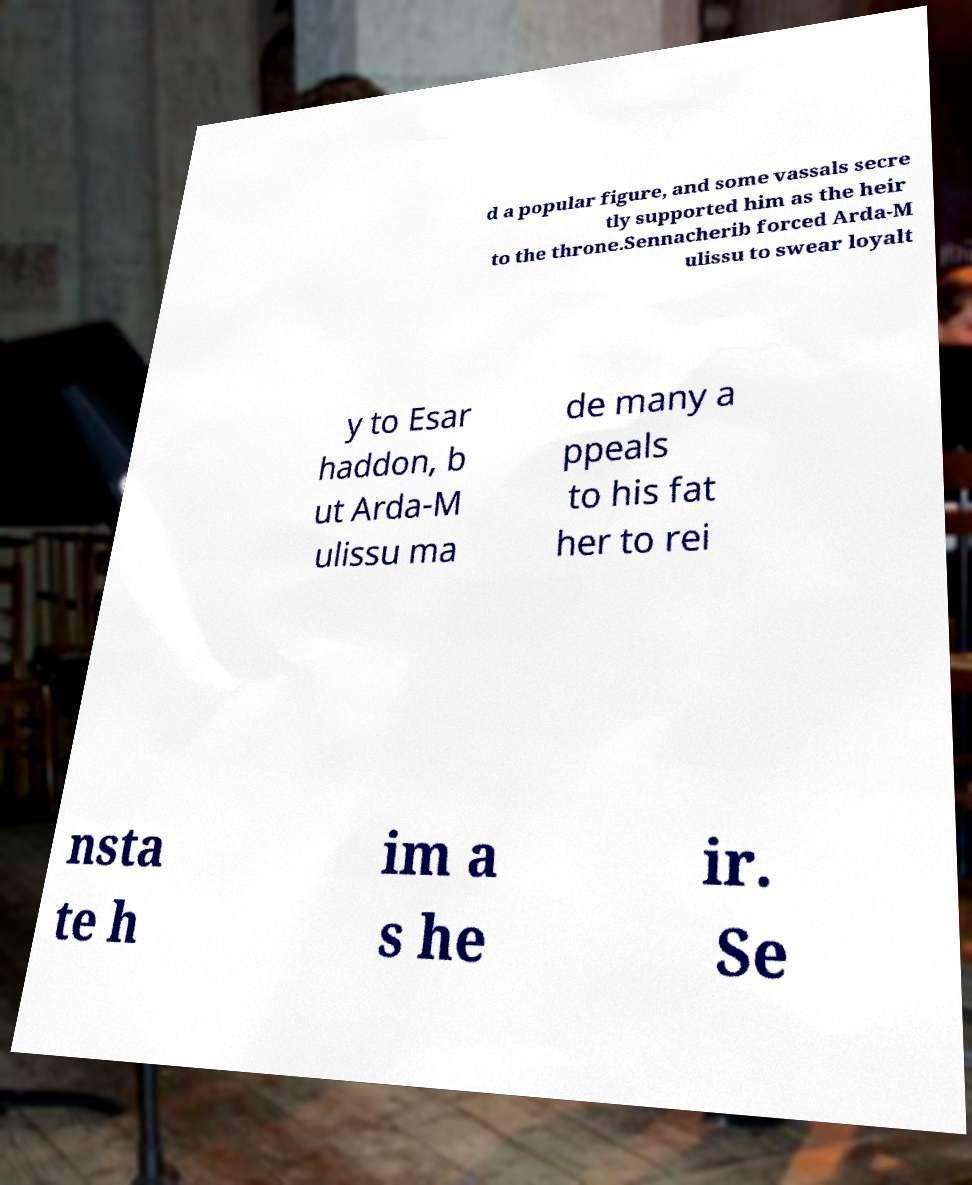There's text embedded in this image that I need extracted. Can you transcribe it verbatim? d a popular figure, and some vassals secre tly supported him as the heir to the throne.Sennacherib forced Arda-M ulissu to swear loyalt y to Esar haddon, b ut Arda-M ulissu ma de many a ppeals to his fat her to rei nsta te h im a s he ir. Se 